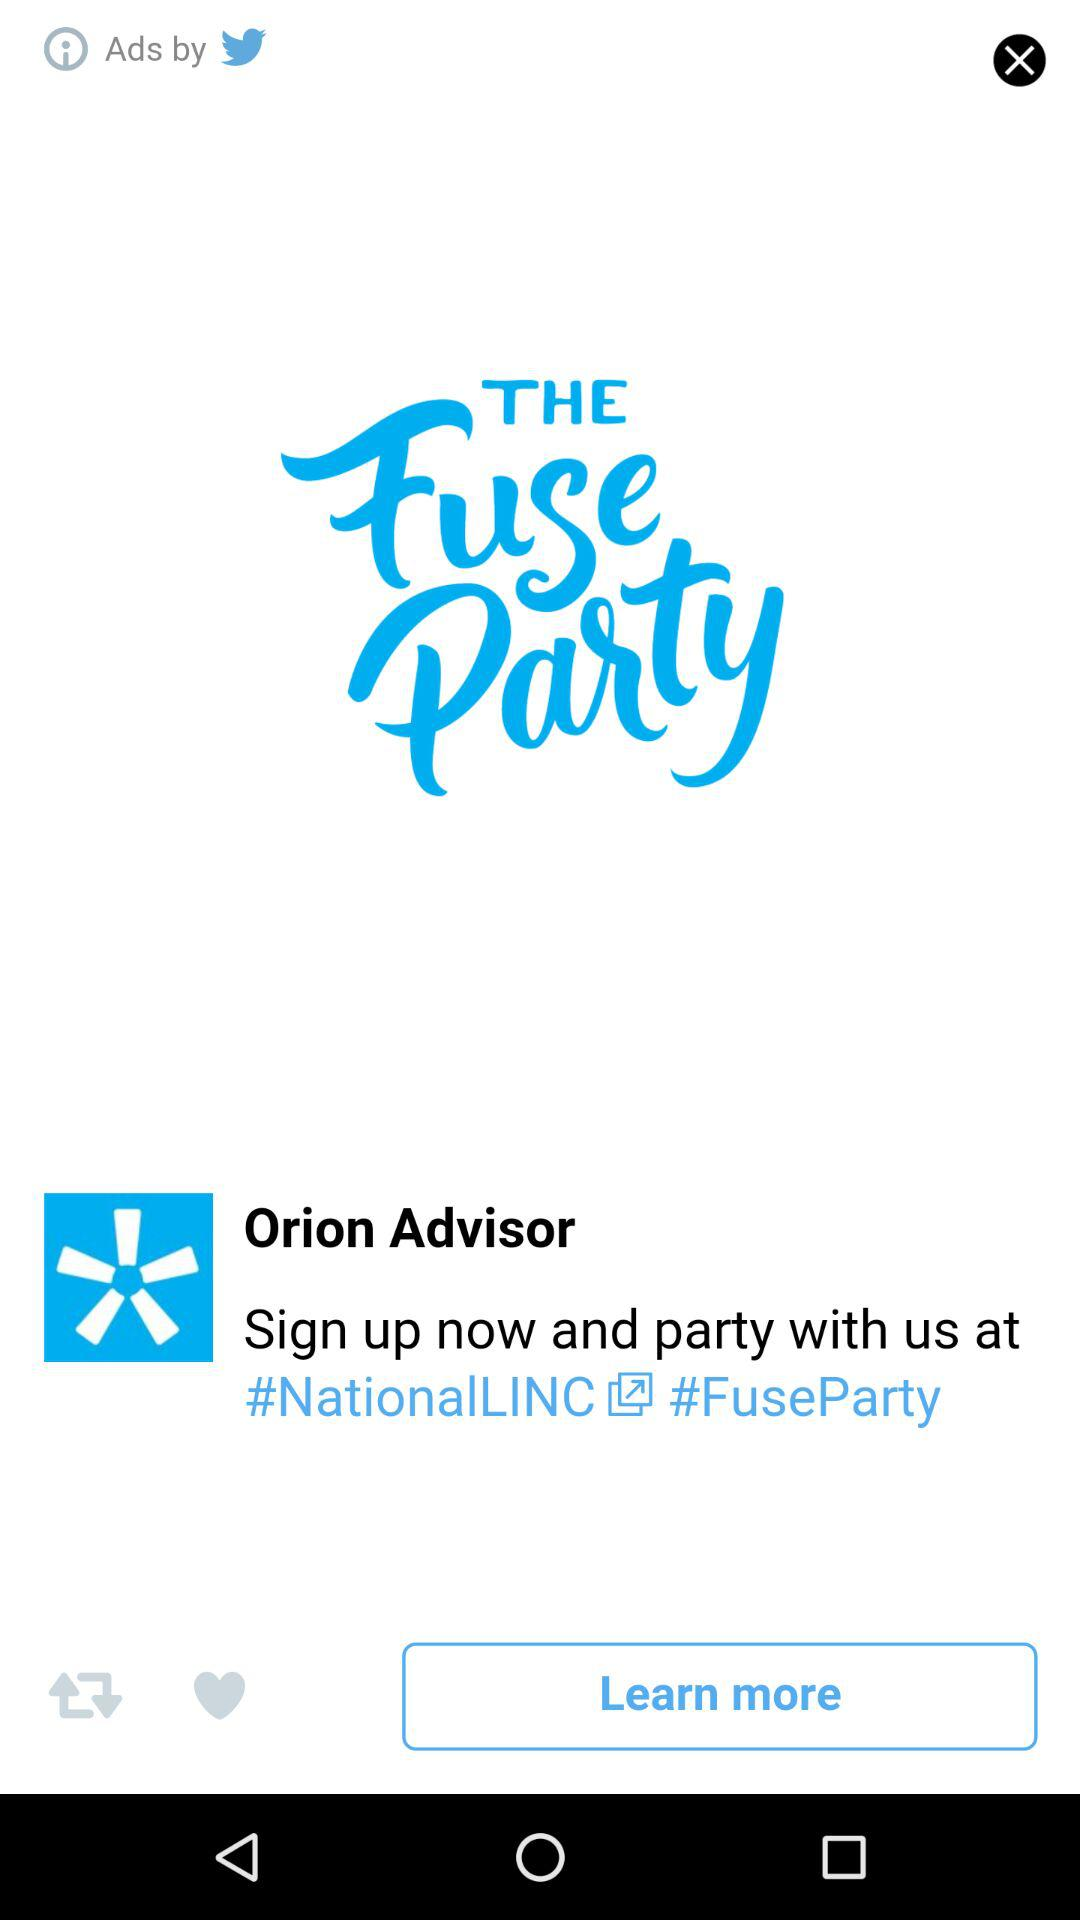What is the application name? The application name is "Orion Mobile". 